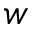Convert formula to latex. <formula><loc_0><loc_0><loc_500><loc_500>w</formula> 